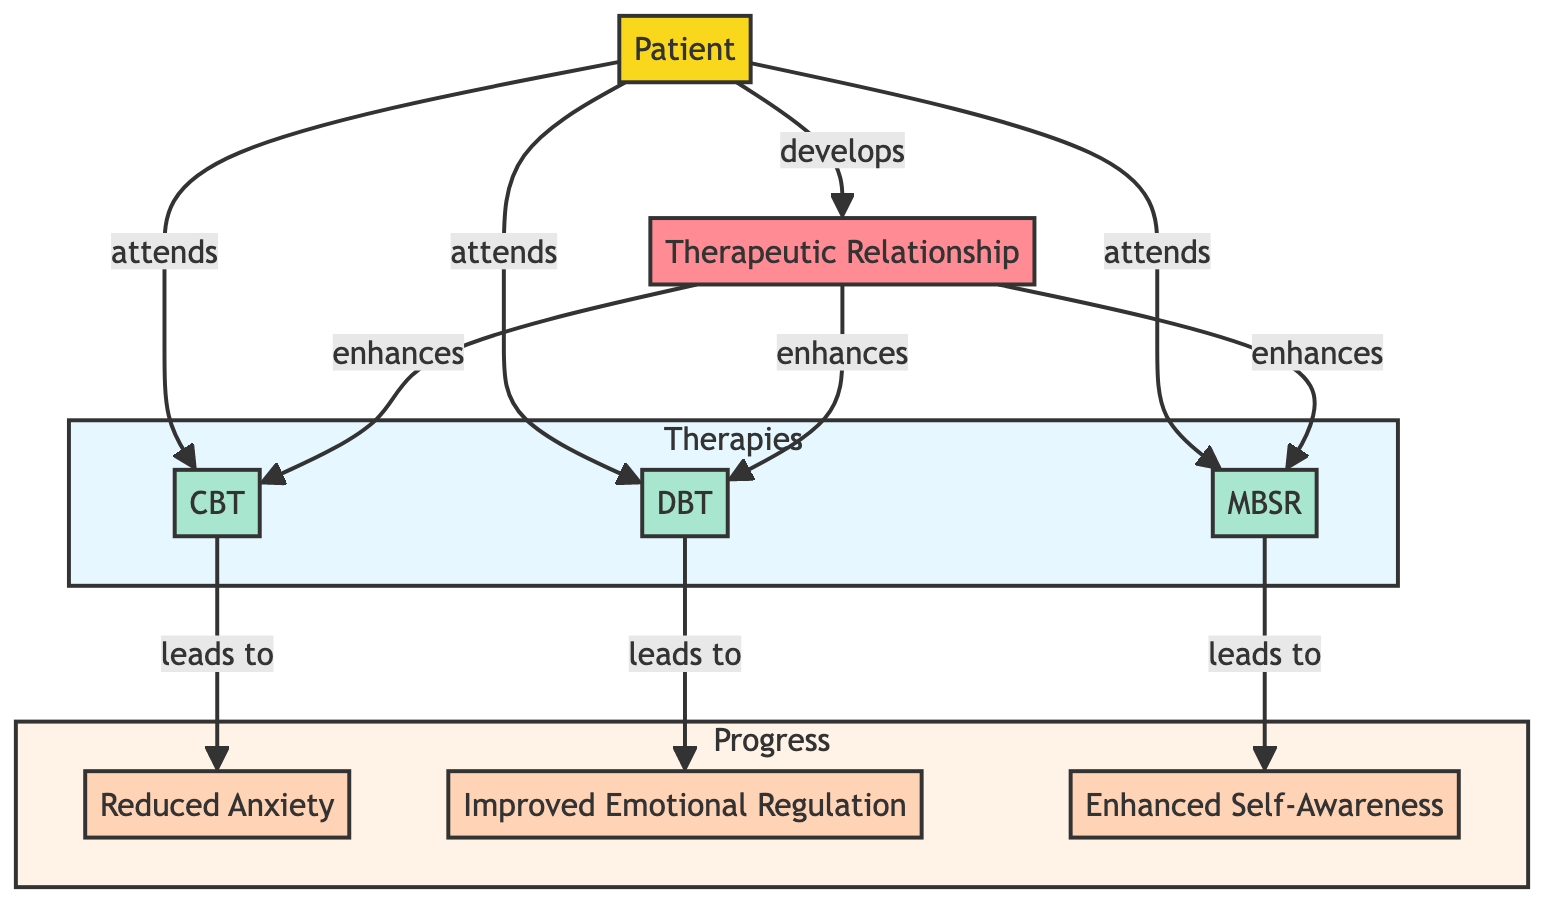What is the number of therapy nodes? The diagram contains three therapy nodes, which are Cognitive Behavioral Therapy (CBT), Dialectical Behavior Therapy (DBT), and Mindfulness-Based Stress Reduction (MBSR). Each node is identified distinctly.
Answer: 3 What type is the node labeled "Patient"? The "Patient" node is identified as a primary node, which indicates it serves as the central node in this therapeutic influence map.
Answer: primary What relationships does the "Therapeutic Relationship" node enhance? The "Therapeutic Relationship" node enhances the relationships to three therapy nodes: CBT, DBT, and MBSR. This shows the impact of the therapeutic relationship on each therapy.
Answer: CBT, DBT, MBSR Which therapy leads to "Reduced Anxiety"? Cognitive Behavioral Therapy (CBT) is the therapy that leads to the progress of Reduced Anxiety, as indicated by the arrow connecting CBT to this progress node.
Answer: CBT What is the total number of edges in the diagram? The diagram has a total of eight edges. This includes connections that indicate attendance, progress leading, and enhancements due to the therapeutic relationship.
Answer: 8 What progresses from attending Dialectical Behavior Therapy (DBT)? The progress from attending DBT is Improved Emotional Regulation, which is shown through the direct link from the DBT node to this progress node.
Answer: Improved Emotional Regulation Why is "Mindfulness-Based Stress Reduction" important in this diagram? Mindfulness-Based Stress Reduction (MBSR) is important as it is one of the therapies that the patient attends, and it leads to Enhanced Self-Awareness, illustrating its influence on the patient's progress.
Answer: Enhances Self-Awareness What does the arrow labeled "leads to" signify in this diagram? The arrows labeled "leads to" signify the direct impact or outcome of a therapy node on a progress node, indicating that participating in the therapy leads to measurable patient progress.
Answer: Outcome of therapy How many progress nodes are there in the diagram? There are three progress nodes, which include Reduced Anxiety, Improved Emotional Regulation, and Enhanced Self-Awareness, showing various outcomes from the therapies attended.
Answer: 3 